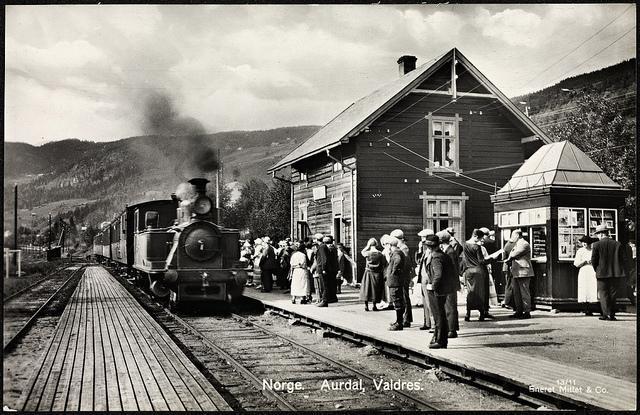How many windows in the building?
Give a very brief answer. 4. 